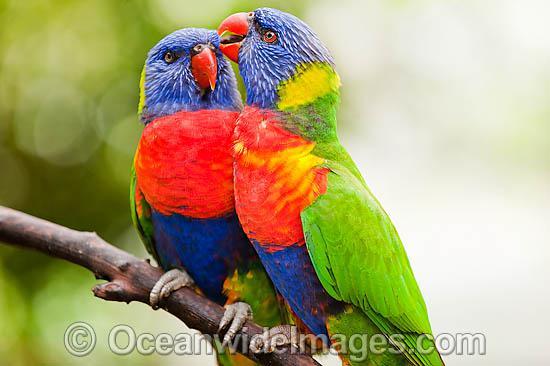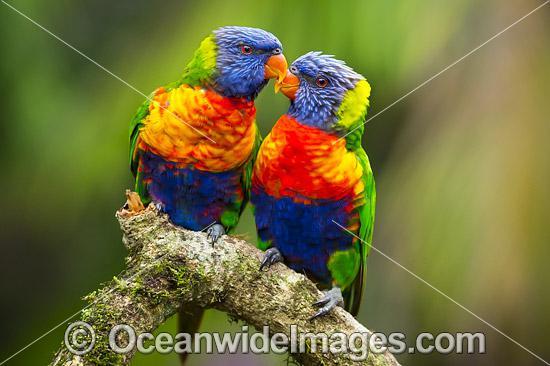The first image is the image on the left, the second image is the image on the right. Evaluate the accuracy of this statement regarding the images: "At least one image shows a colorful bird with its wings spread". Is it true? Answer yes or no. No. The first image is the image on the left, the second image is the image on the right. Given the left and right images, does the statement "There are four birds perched together in groups of two." hold true? Answer yes or no. Yes. 